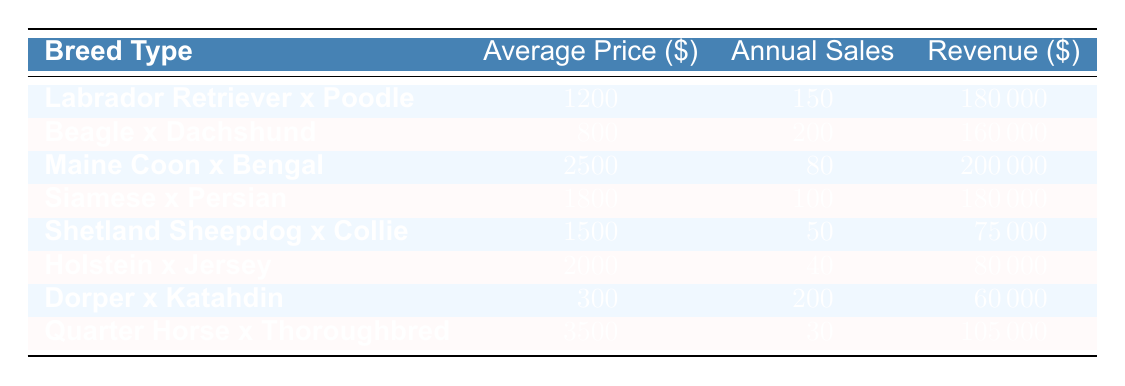What is the average price of the Labrador Retriever x Poodle crossbred animals? Referring to the table, the average price of the Labrador Retriever x Poodle is stated directly, which is 1200 dollars.
Answer: 1200 How many annual sales were recorded for the Beagle x Dachshund? The table indicates the annual sales for the Beagle x Dachshund breed type, which are listed as 200.
Answer: 200 Which crossbred animal generated the highest revenue and what was that amount? By comparing the revenue figures listed in the table, the Maine Coon x Bengal generated the highest revenue of 200000 dollars.
Answer: Maine Coon x Bengal, 200000 What is the total revenue generated from the sales of all crossbred animals listed? To find the total revenue, add up the revenues of all crossbred animals: 180000 + 160000 + 200000 + 180000 + 75000 + 80000 + 60000 + 105000 = 1,060,000 dollars.
Answer: 1,060,000 Is it true that the average price for the Holstein x Jersey is greater than 1500 dollars? The average price for the Holstein x Jersey is listed as 2000 dollars. Since 2000 is greater than 1500, the statement is true.
Answer: Yes Which two breed types have similar annual sales around 100? The Siamese x Persian has 100 annual sales, and the Labrador Retriever x Poodle has significantly more. Considering the figures in the table, no two breed types closely match around 100, but if you look for numbers close to each other aside from that, 80 (Maine Coon x Bengal) and 100 (Siamese x Persian) can be relatively compared.
Answer: Siamese x Persian and Maine Coon x Bengal What is the difference in revenue between the Labrador Retriever x Poodle and the Quarter Horse x Thoroughbred? The revenue for Labrador Retriever x Poodle is 180000 dollars, while for Quarter Horse x Thoroughbred it is 105000 dollars. The difference is calculated as 180000 - 105000 = 75000 dollars.
Answer: 75000 What average price is associated with the Dorper x Katahdin? According to the data, the average price of the Dorper x Katahdin is provided directly as 300 dollars.
Answer: 300 Is the total number of annual sales for the Shetland Sheepdog x Collie and Holstein x Jersey less than 100? The total annual sales for Shetland Sheepdog x Collie is 50, and for Holstein x Jersey, it is 40. Adding these together gives 50 + 40 = 90, which is less than 100. Therefore, the statement is true.
Answer: Yes 